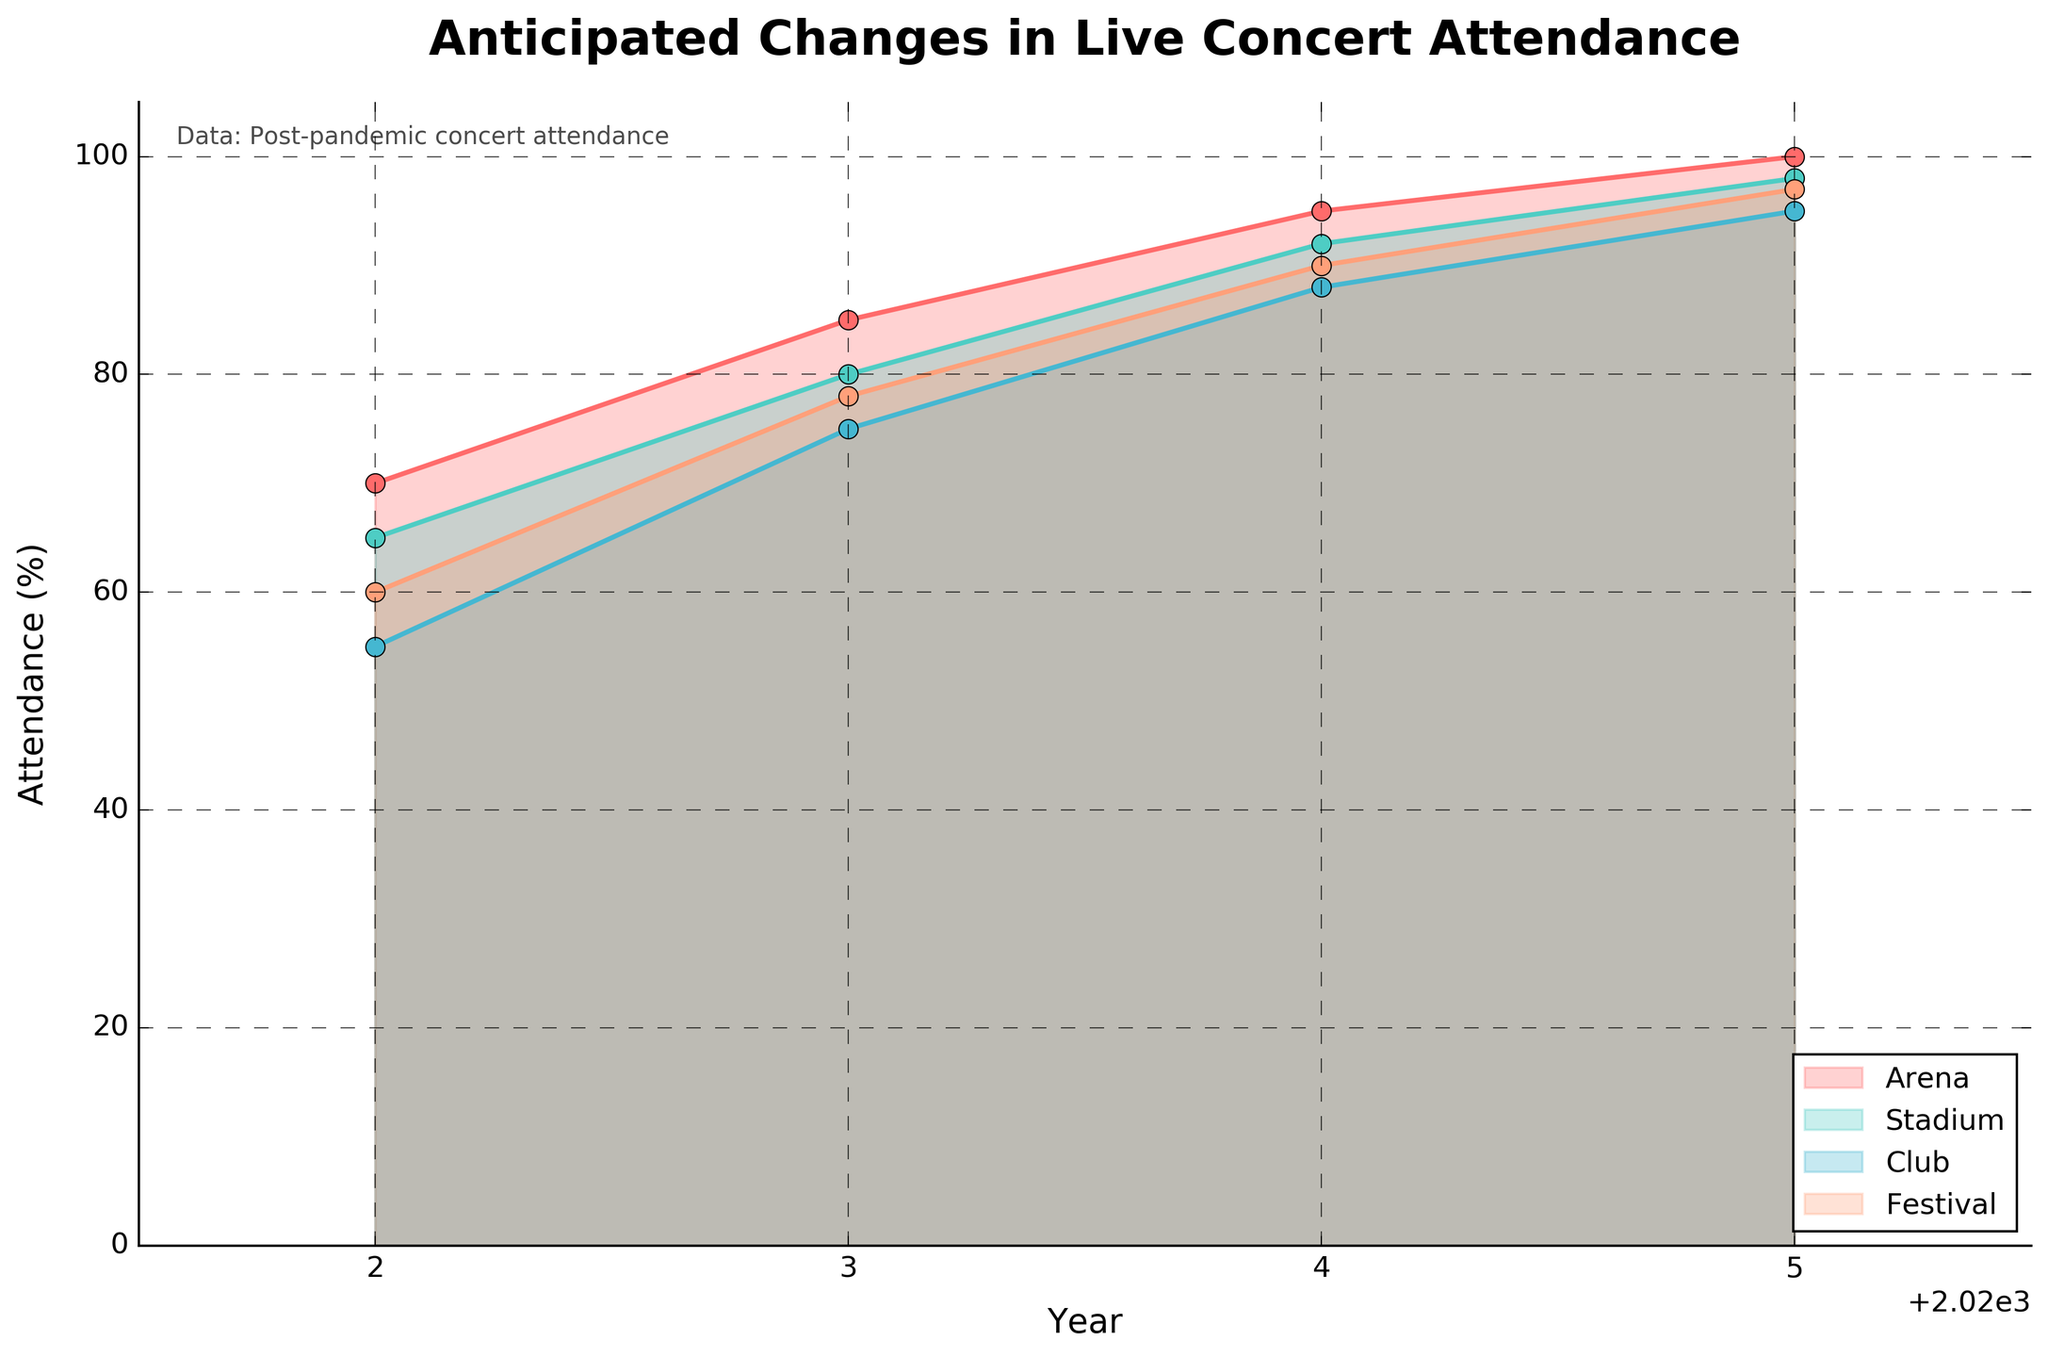What is the title of the figure? The title of the figure is at the very top of the chart and it reads "Anticipated Changes in Live Concert Attendance".
Answer: Anticipated Changes in Live Concert Attendance How many venue types are displayed in the figure? The figure shows different regions filled with colors, each labeled; there are four types of venues: Arena, Stadium, Club, and Festival.
Answer: 4 Which venue type has the highest anticipated attendance in 2025? Look at the data points and filled regions for the year 2025; Arena reaches the top-most point at 100%.
Answer: Arena Compare the anticipated attendance between Stadium and Festival in 2024. Which one is higher? Locate the lines and fill areas for Stadium and Festival in the year 2024; Stadium is at 92% while Festival is at 90%.
Answer: Stadium What's the average anticipated attendance across all venue types in 2023? Sum the data points for Arena (85), Stadium (80), Club (75), and Festival (78) and divide by 4: (85+80+75+78)/4 = 79.5.
Answer: 79.5 Which genre shows the most significant increase from 2022 to 2023? Look at the data points for each genre from 2022 to 2023 and find the maximum increase; Pop increases from 65 to 82, a change of 17%.
Answer: Pop What is the lowest anticipated attendance overall in the year 2022? Identify the smallest filled area in 2022; Club has the lowest attendance at 55%.
Answer: Club How do the anticipated attendances in 2025 for Arena and Stadium compare? Both Arena and Stadium have the same data point at the year 2025 with an attendance of 100% and 98% respectively.
Answer: Arena is higher Is the trend for anticipated attendance increasing or decreasing over the years 2022 to 2025? Review the slopes of the lines and overall direction from 2022 to 2025 across all venue types; they all show an upward trend.
Answer: Increasing 